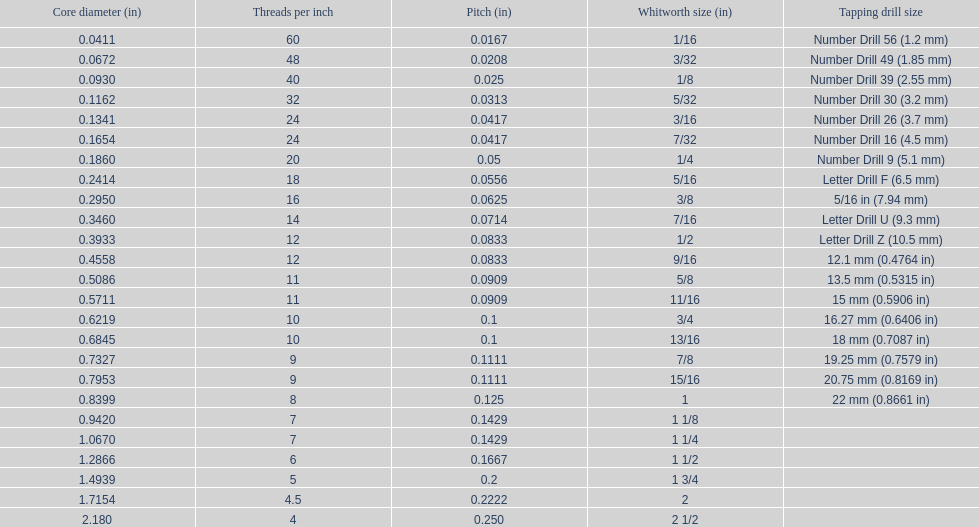What is the core diameter of the last whitworth thread size? 2.180. 